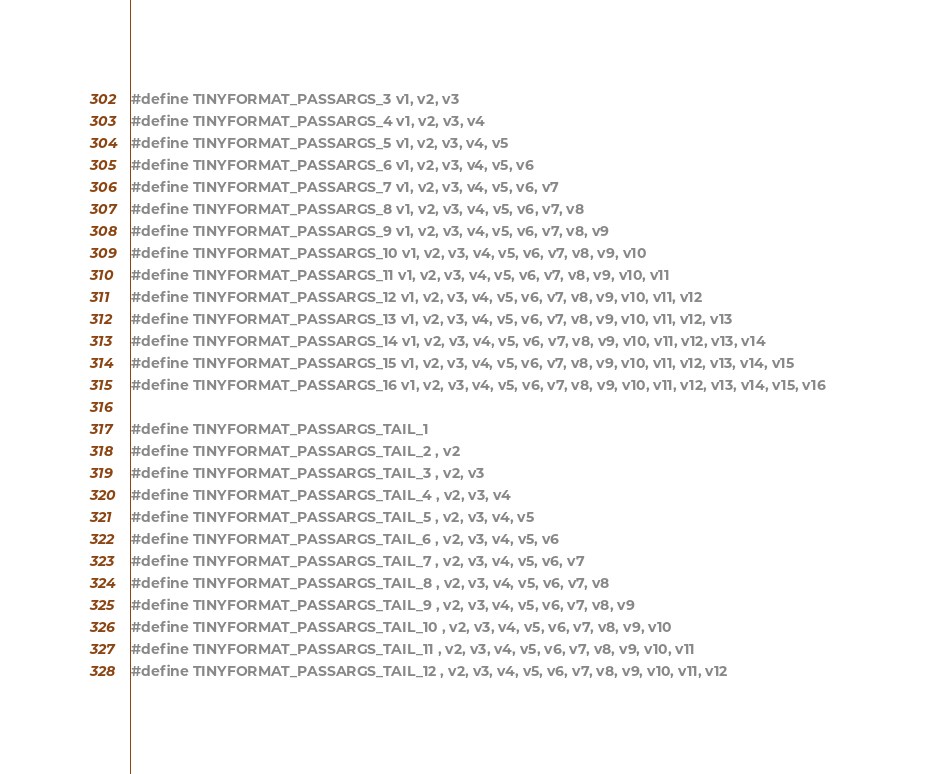<code> <loc_0><loc_0><loc_500><loc_500><_C_>#define TINYFORMAT_PASSARGS_3 v1, v2, v3
#define TINYFORMAT_PASSARGS_4 v1, v2, v3, v4
#define TINYFORMAT_PASSARGS_5 v1, v2, v3, v4, v5
#define TINYFORMAT_PASSARGS_6 v1, v2, v3, v4, v5, v6
#define TINYFORMAT_PASSARGS_7 v1, v2, v3, v4, v5, v6, v7
#define TINYFORMAT_PASSARGS_8 v1, v2, v3, v4, v5, v6, v7, v8
#define TINYFORMAT_PASSARGS_9 v1, v2, v3, v4, v5, v6, v7, v8, v9
#define TINYFORMAT_PASSARGS_10 v1, v2, v3, v4, v5, v6, v7, v8, v9, v10
#define TINYFORMAT_PASSARGS_11 v1, v2, v3, v4, v5, v6, v7, v8, v9, v10, v11
#define TINYFORMAT_PASSARGS_12 v1, v2, v3, v4, v5, v6, v7, v8, v9, v10, v11, v12
#define TINYFORMAT_PASSARGS_13 v1, v2, v3, v4, v5, v6, v7, v8, v9, v10, v11, v12, v13
#define TINYFORMAT_PASSARGS_14 v1, v2, v3, v4, v5, v6, v7, v8, v9, v10, v11, v12, v13, v14
#define TINYFORMAT_PASSARGS_15 v1, v2, v3, v4, v5, v6, v7, v8, v9, v10, v11, v12, v13, v14, v15
#define TINYFORMAT_PASSARGS_16 v1, v2, v3, v4, v5, v6, v7, v8, v9, v10, v11, v12, v13, v14, v15, v16

#define TINYFORMAT_PASSARGS_TAIL_1
#define TINYFORMAT_PASSARGS_TAIL_2 , v2
#define TINYFORMAT_PASSARGS_TAIL_3 , v2, v3
#define TINYFORMAT_PASSARGS_TAIL_4 , v2, v3, v4
#define TINYFORMAT_PASSARGS_TAIL_5 , v2, v3, v4, v5
#define TINYFORMAT_PASSARGS_TAIL_6 , v2, v3, v4, v5, v6
#define TINYFORMAT_PASSARGS_TAIL_7 , v2, v3, v4, v5, v6, v7
#define TINYFORMAT_PASSARGS_TAIL_8 , v2, v3, v4, v5, v6, v7, v8
#define TINYFORMAT_PASSARGS_TAIL_9 , v2, v3, v4, v5, v6, v7, v8, v9
#define TINYFORMAT_PASSARGS_TAIL_10 , v2, v3, v4, v5, v6, v7, v8, v9, v10
#define TINYFORMAT_PASSARGS_TAIL_11 , v2, v3, v4, v5, v6, v7, v8, v9, v10, v11
#define TINYFORMAT_PASSARGS_TAIL_12 , v2, v3, v4, v5, v6, v7, v8, v9, v10, v11, v12</code> 